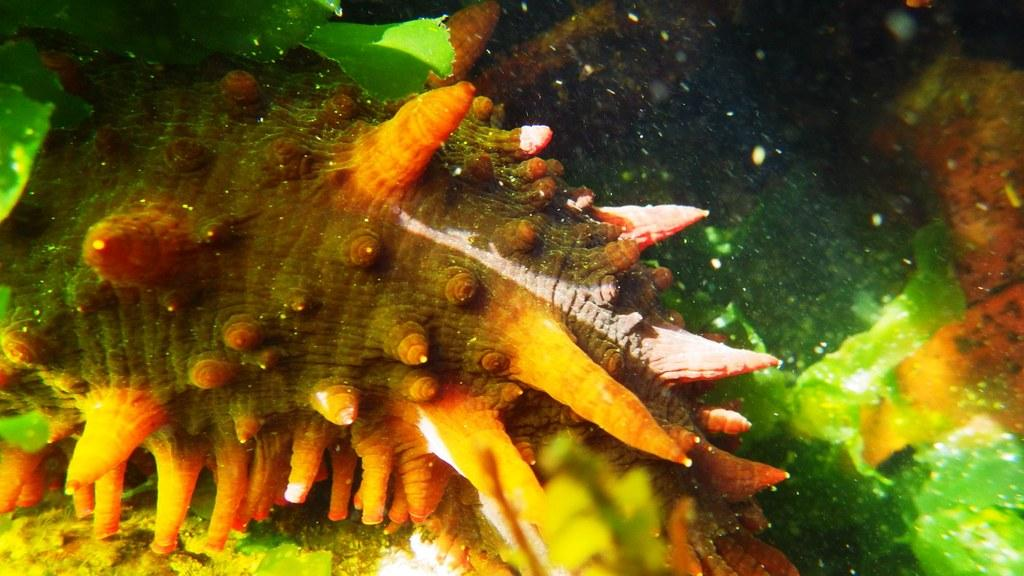What type of animal can be seen in the image? There is a water animal in the image. What is present in the water with the animal? There is algae in the image. What type of juice is being squeezed by the water animal in the image? There is no juice or any squeezing action depicted in the image; it features a water animal and algae. 